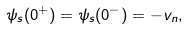<formula> <loc_0><loc_0><loc_500><loc_500>\psi _ { s } ( 0 ^ { + } ) = \psi _ { s } ( 0 ^ { - } ) = - v _ { n } ,</formula> 